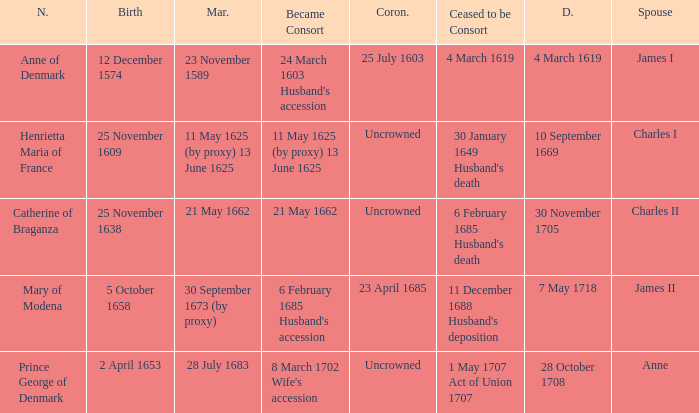On what date did James II take a consort? 6 February 1685 Husband's accession. 